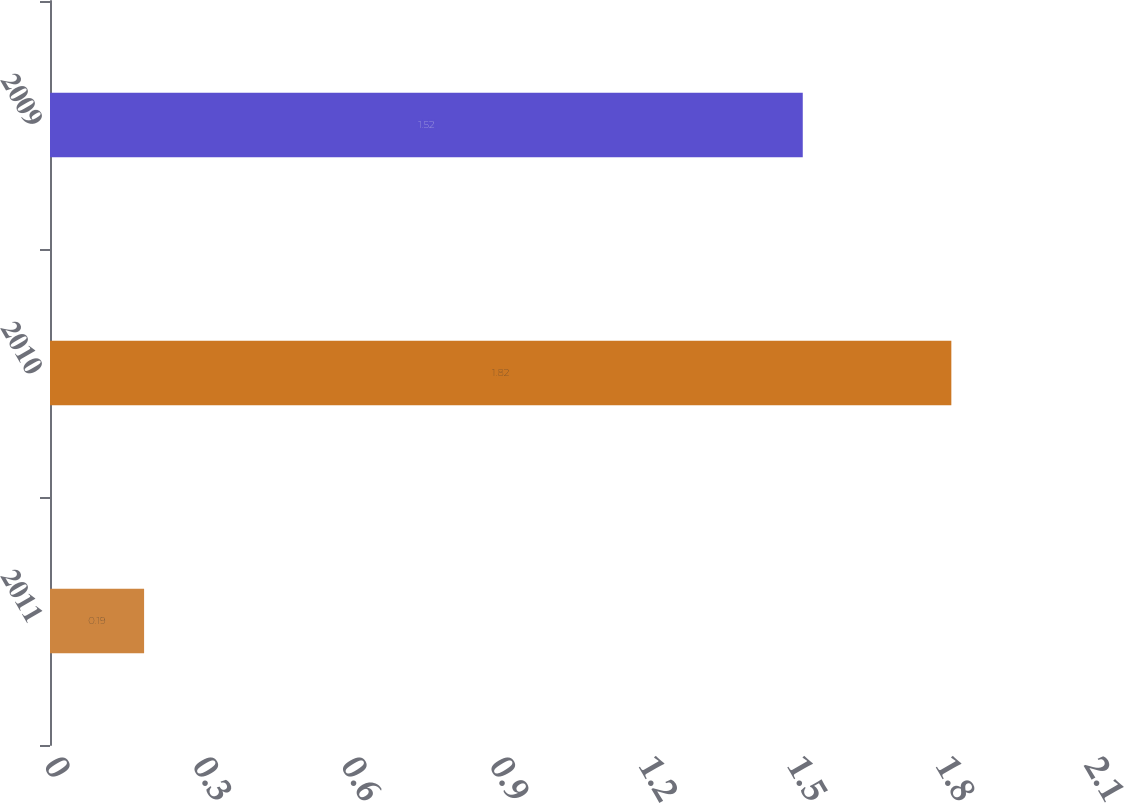Convert chart. <chart><loc_0><loc_0><loc_500><loc_500><bar_chart><fcel>2011<fcel>2010<fcel>2009<nl><fcel>0.19<fcel>1.82<fcel>1.52<nl></chart> 